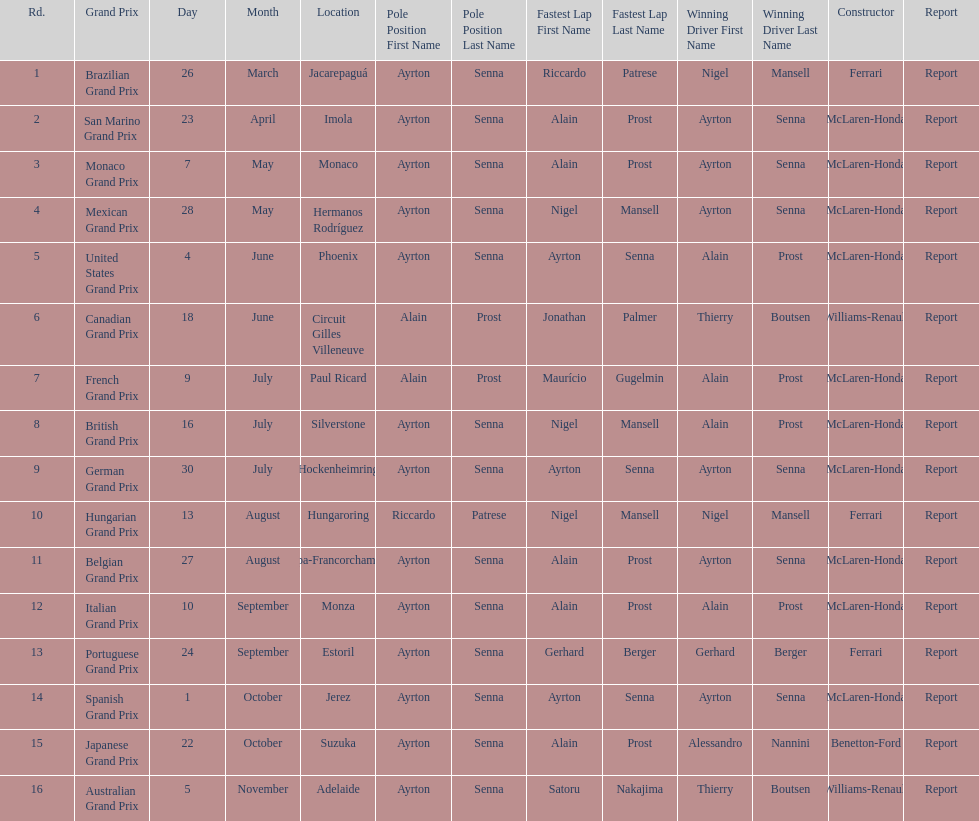Prost won the drivers title, who was his teammate? Ayrton Senna. 